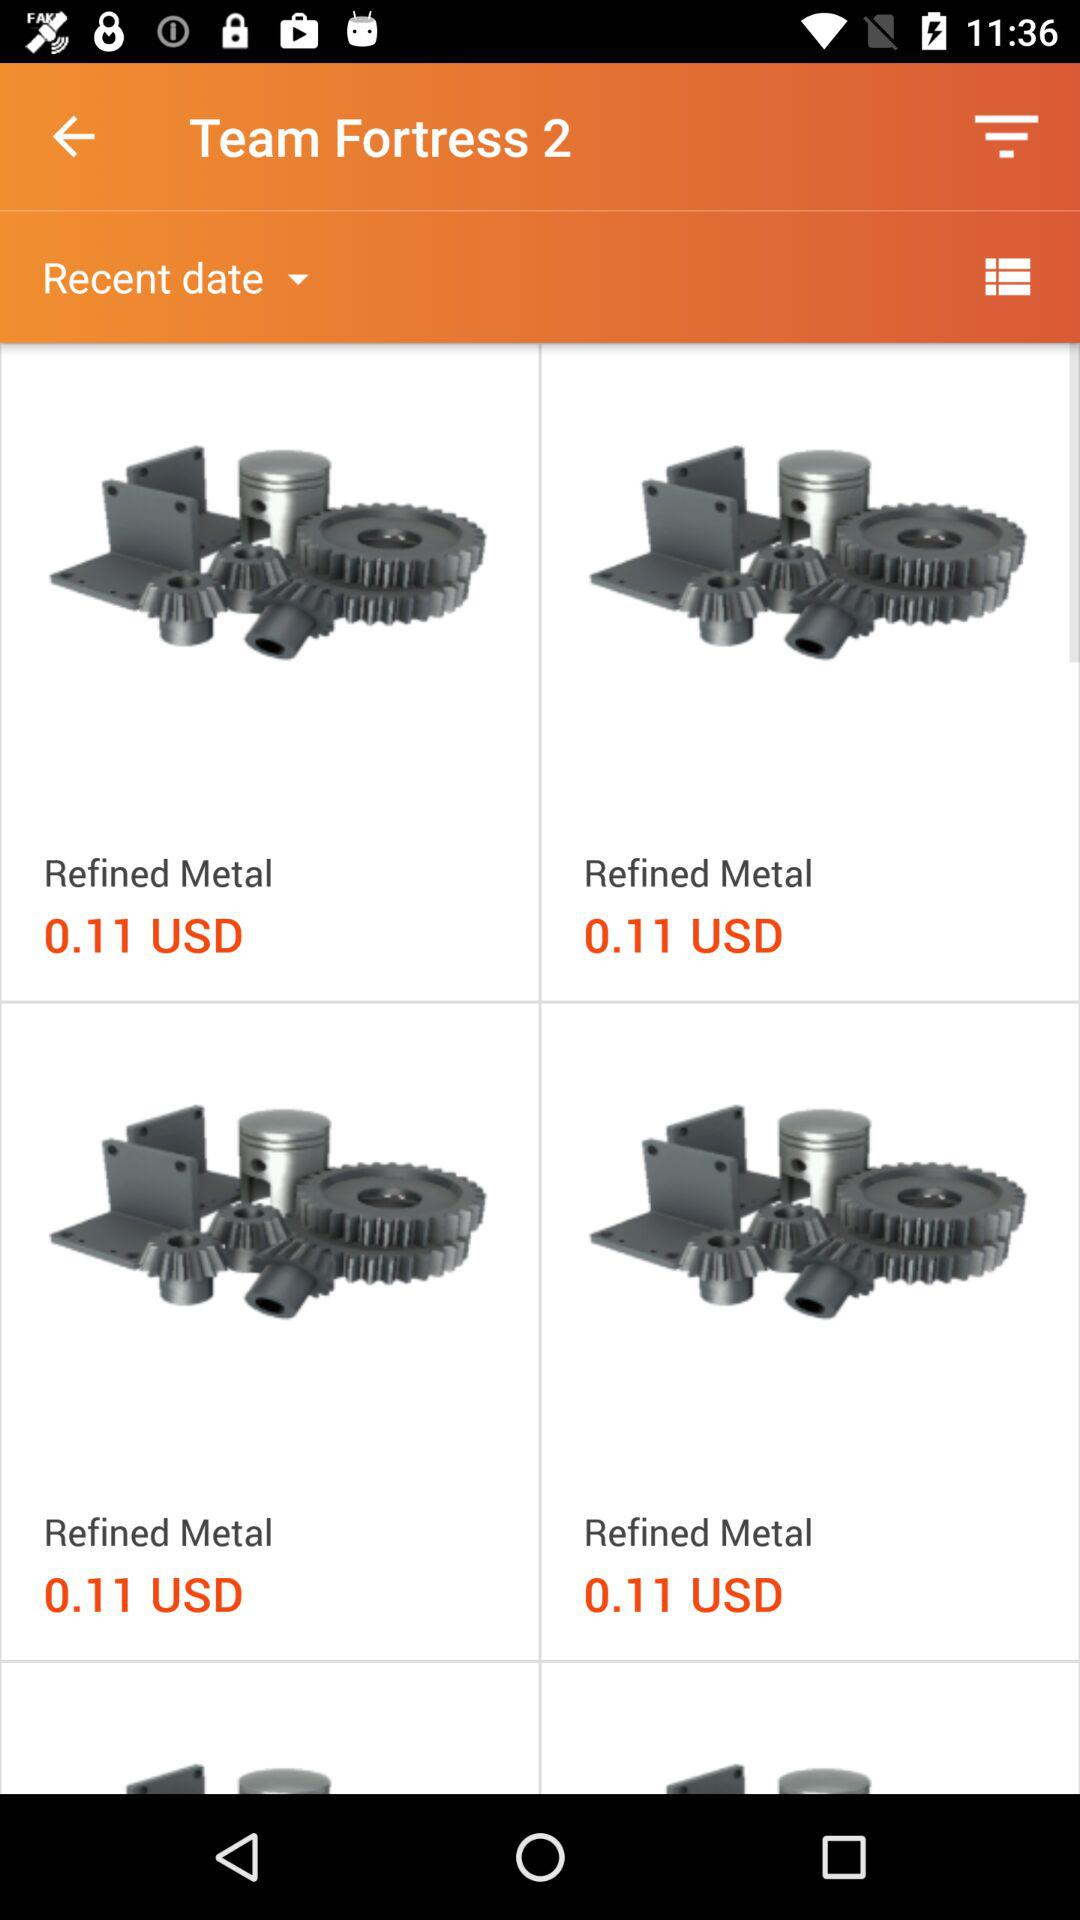What is the date?
When the provided information is insufficient, respond with <no answer>. <no answer> 